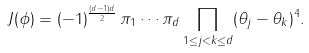<formula> <loc_0><loc_0><loc_500><loc_500>J ( \phi ) = ( - 1 ) ^ { \frac { ( d - 1 ) d } { 2 } } \, \pi _ { 1 } \cdots \pi _ { d } \prod _ { 1 \leq j < k \leq d } ( \theta _ { j } - \theta _ { k } ) ^ { 4 } .</formula> 